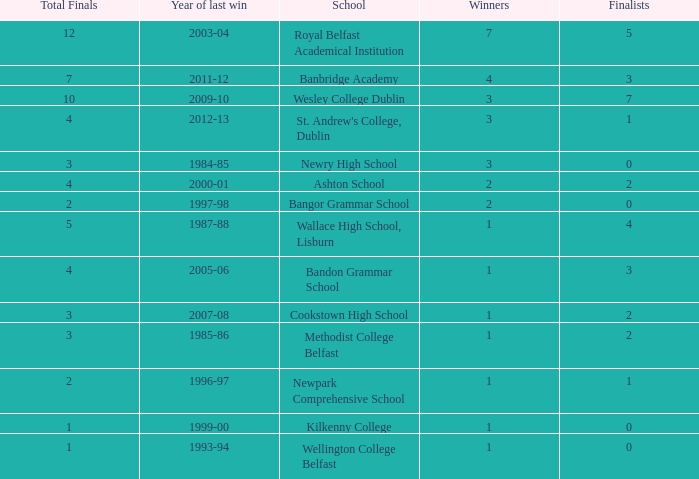What are the names that had a finalist score of 2? Ashton School, Cookstown High School, Methodist College Belfast. 